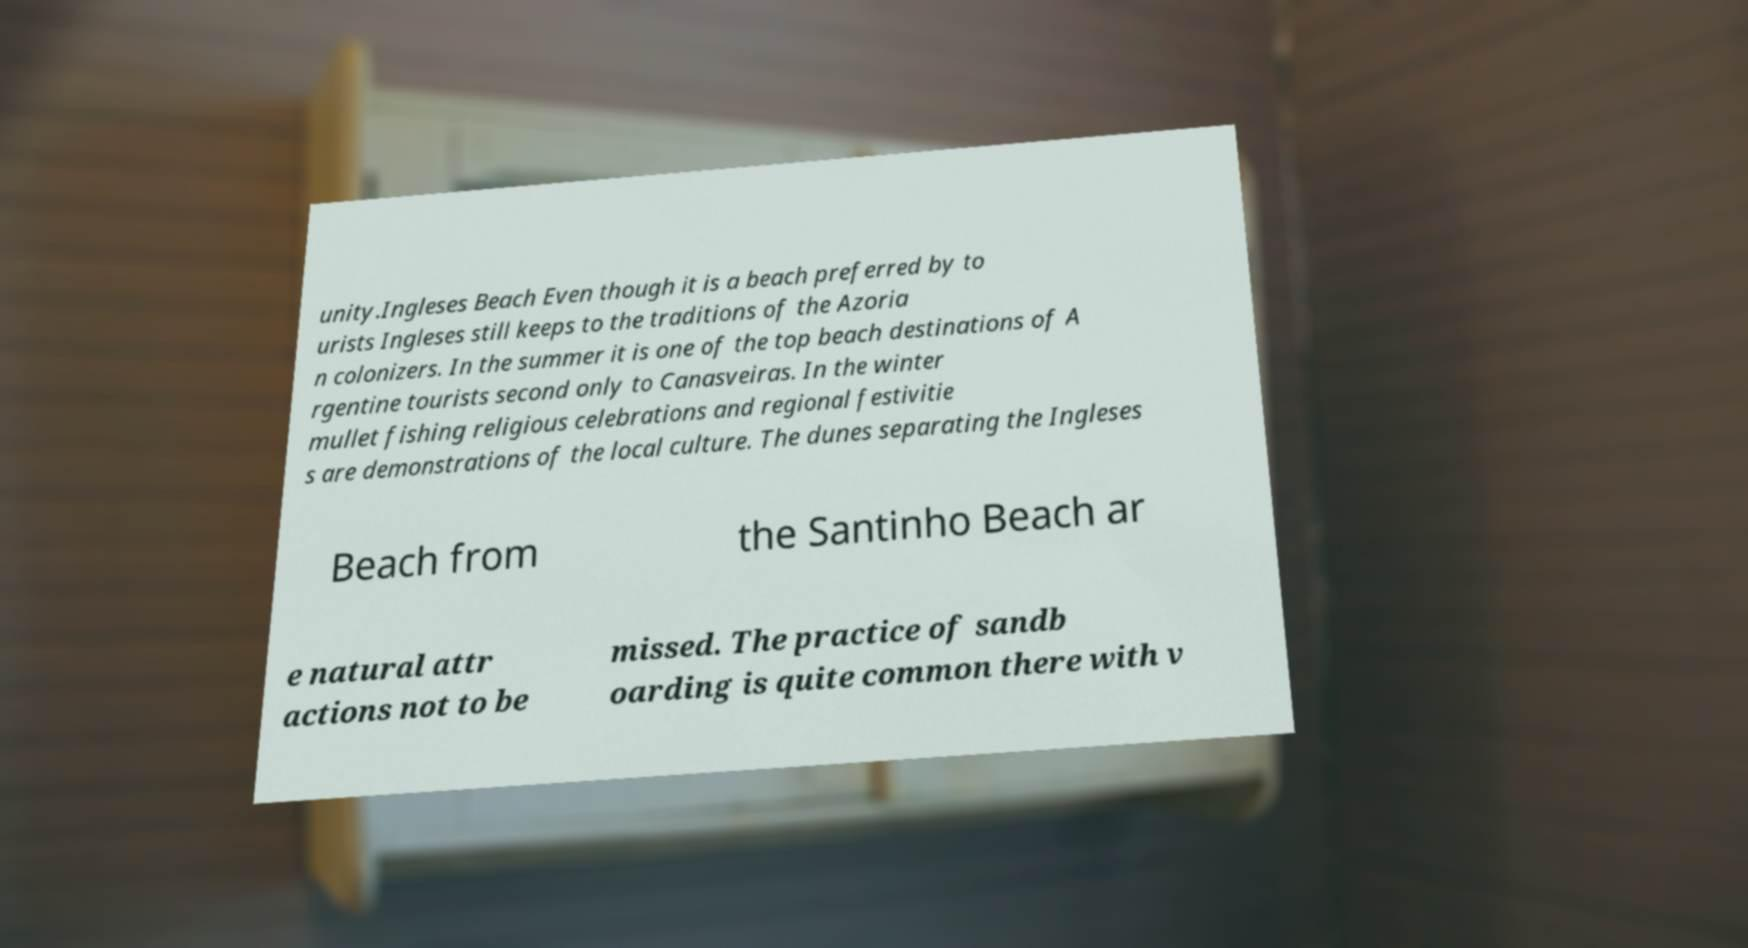Could you extract and type out the text from this image? unity.Ingleses Beach Even though it is a beach preferred by to urists Ingleses still keeps to the traditions of the Azoria n colonizers. In the summer it is one of the top beach destinations of A rgentine tourists second only to Canasveiras. In the winter mullet fishing religious celebrations and regional festivitie s are demonstrations of the local culture. The dunes separating the Ingleses Beach from the Santinho Beach ar e natural attr actions not to be missed. The practice of sandb oarding is quite common there with v 